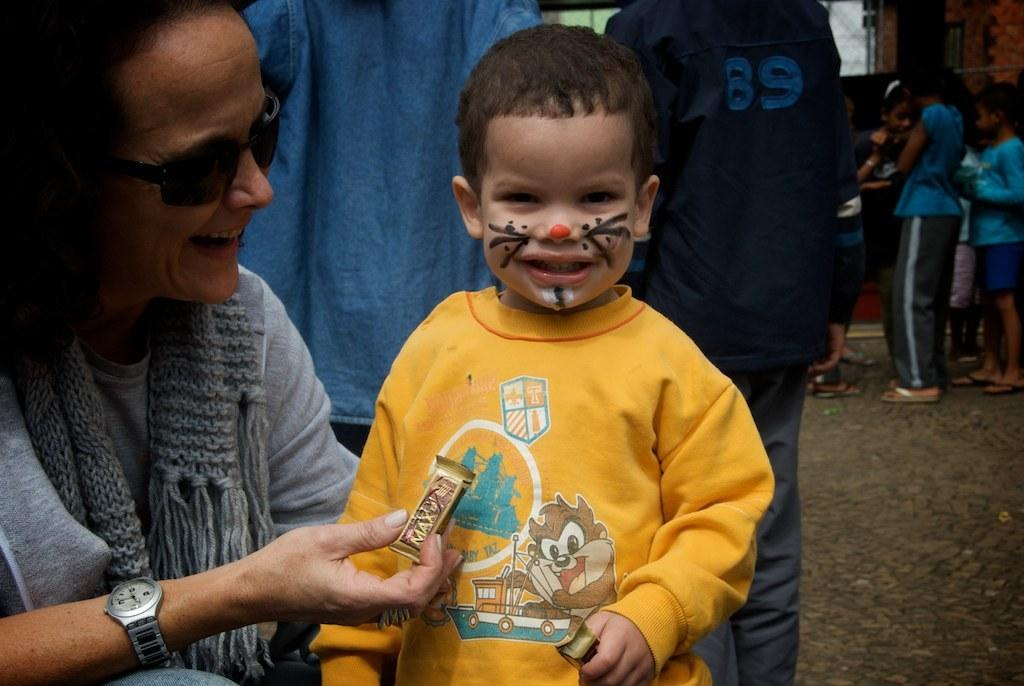How many people are in the image? There is a group of people in the image. What can be observed about the clothing of the people in the image? The people are wearing different color dresses. Can you describe any specific accessory worn by one of the people in the image? One person is wearing goggles. What is the person with goggles holding in the image? The person with goggles is holding something. What type of gold object can be seen in the image? There is no gold object present in the image. Can you tell me how many bottles are visible in the image? There is no bottle present in the image. 